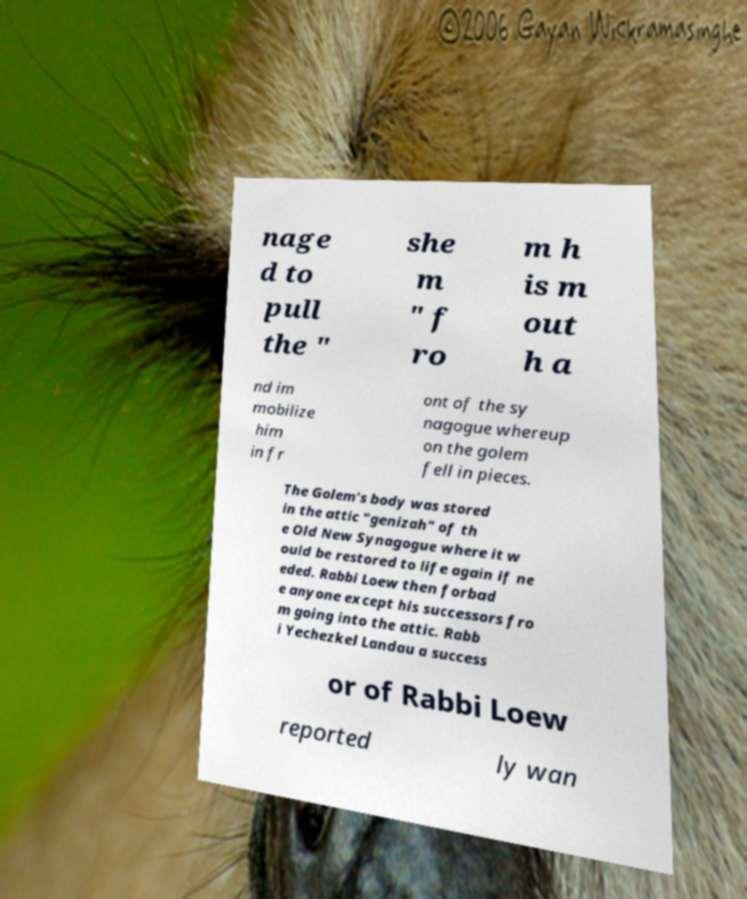Can you read and provide the text displayed in the image?This photo seems to have some interesting text. Can you extract and type it out for me? nage d to pull the " she m " f ro m h is m out h a nd im mobilize him in fr ont of the sy nagogue whereup on the golem fell in pieces. The Golem's body was stored in the attic "genizah" of th e Old New Synagogue where it w ould be restored to life again if ne eded. Rabbi Loew then forbad e anyone except his successors fro m going into the attic. Rabb i Yechezkel Landau a success or of Rabbi Loew reported ly wan 